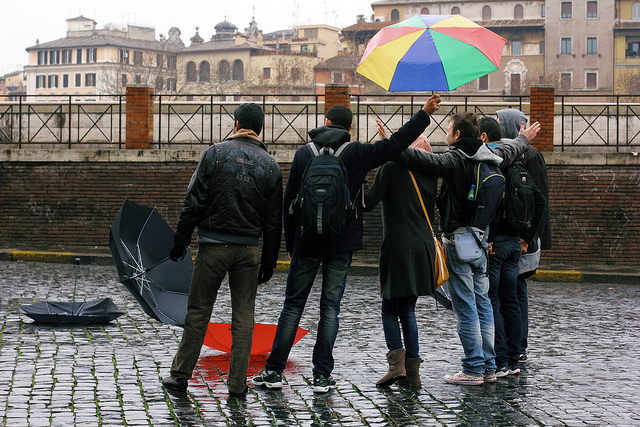How many backpacks can be seen? 3 